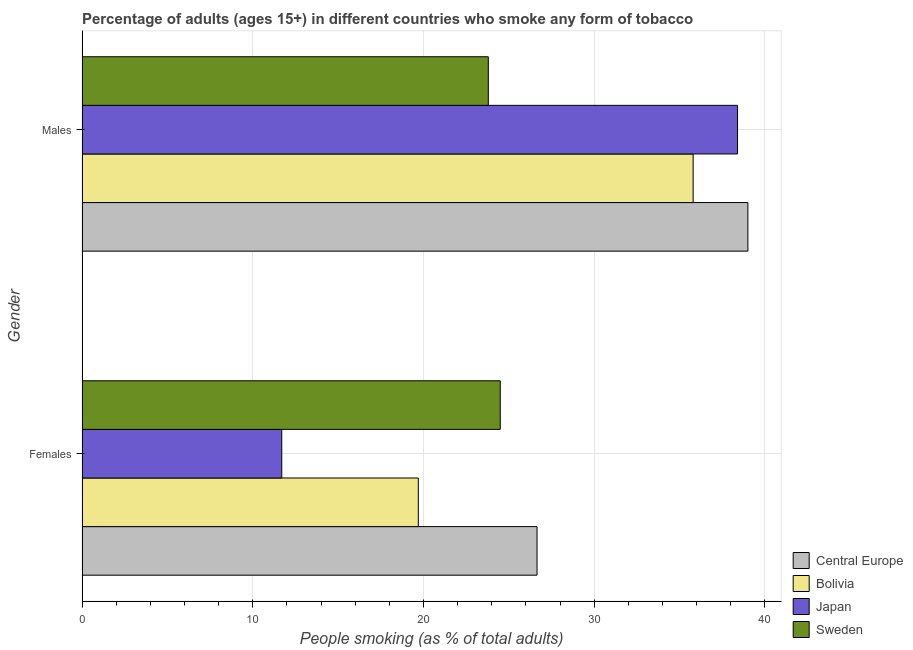How many groups of bars are there?
Offer a terse response. 2. Are the number of bars on each tick of the Y-axis equal?
Make the answer very short. Yes. What is the label of the 2nd group of bars from the top?
Provide a short and direct response. Females. What is the percentage of females who smoke in Sweden?
Offer a very short reply. 24.5. Across all countries, what is the maximum percentage of males who smoke?
Make the answer very short. 39.01. Across all countries, what is the minimum percentage of females who smoke?
Your answer should be very brief. 11.7. In which country was the percentage of males who smoke maximum?
Ensure brevity in your answer.  Central Europe. In which country was the percentage of males who smoke minimum?
Make the answer very short. Sweden. What is the total percentage of males who smoke in the graph?
Ensure brevity in your answer.  137.01. What is the difference between the percentage of males who smoke in Sweden and that in Bolivia?
Keep it short and to the point. -12. What is the difference between the percentage of females who smoke in Bolivia and the percentage of males who smoke in Japan?
Your answer should be compact. -18.7. What is the average percentage of females who smoke per country?
Your answer should be very brief. 20.64. What is the difference between the percentage of males who smoke and percentage of females who smoke in Central Europe?
Your response must be concise. 12.35. In how many countries, is the percentage of females who smoke greater than 14 %?
Provide a succinct answer. 3. What is the ratio of the percentage of males who smoke in Bolivia to that in Japan?
Offer a terse response. 0.93. What does the 3rd bar from the top in Males represents?
Offer a very short reply. Bolivia. Are all the bars in the graph horizontal?
Keep it short and to the point. Yes. Does the graph contain any zero values?
Your answer should be compact. No. Does the graph contain grids?
Give a very brief answer. Yes. How many legend labels are there?
Your answer should be compact. 4. What is the title of the graph?
Offer a very short reply. Percentage of adults (ages 15+) in different countries who smoke any form of tobacco. What is the label or title of the X-axis?
Give a very brief answer. People smoking (as % of total adults). What is the People smoking (as % of total adults) in Central Europe in Females?
Keep it short and to the point. 26.65. What is the People smoking (as % of total adults) in Central Europe in Males?
Offer a terse response. 39.01. What is the People smoking (as % of total adults) in Bolivia in Males?
Your answer should be very brief. 35.8. What is the People smoking (as % of total adults) in Japan in Males?
Offer a very short reply. 38.4. What is the People smoking (as % of total adults) of Sweden in Males?
Provide a short and direct response. 23.8. Across all Gender, what is the maximum People smoking (as % of total adults) of Central Europe?
Your answer should be very brief. 39.01. Across all Gender, what is the maximum People smoking (as % of total adults) of Bolivia?
Ensure brevity in your answer.  35.8. Across all Gender, what is the maximum People smoking (as % of total adults) of Japan?
Your answer should be compact. 38.4. Across all Gender, what is the maximum People smoking (as % of total adults) of Sweden?
Your answer should be very brief. 24.5. Across all Gender, what is the minimum People smoking (as % of total adults) in Central Europe?
Provide a succinct answer. 26.65. Across all Gender, what is the minimum People smoking (as % of total adults) of Bolivia?
Your answer should be compact. 19.7. Across all Gender, what is the minimum People smoking (as % of total adults) in Japan?
Provide a short and direct response. 11.7. Across all Gender, what is the minimum People smoking (as % of total adults) in Sweden?
Your answer should be very brief. 23.8. What is the total People smoking (as % of total adults) in Central Europe in the graph?
Your answer should be very brief. 65.66. What is the total People smoking (as % of total adults) of Bolivia in the graph?
Keep it short and to the point. 55.5. What is the total People smoking (as % of total adults) in Japan in the graph?
Give a very brief answer. 50.1. What is the total People smoking (as % of total adults) in Sweden in the graph?
Your response must be concise. 48.3. What is the difference between the People smoking (as % of total adults) in Central Europe in Females and that in Males?
Offer a very short reply. -12.35. What is the difference between the People smoking (as % of total adults) of Bolivia in Females and that in Males?
Provide a short and direct response. -16.1. What is the difference between the People smoking (as % of total adults) of Japan in Females and that in Males?
Your response must be concise. -26.7. What is the difference between the People smoking (as % of total adults) of Central Europe in Females and the People smoking (as % of total adults) of Bolivia in Males?
Provide a short and direct response. -9.14. What is the difference between the People smoking (as % of total adults) in Central Europe in Females and the People smoking (as % of total adults) in Japan in Males?
Make the answer very short. -11.74. What is the difference between the People smoking (as % of total adults) of Central Europe in Females and the People smoking (as % of total adults) of Sweden in Males?
Provide a short and direct response. 2.85. What is the difference between the People smoking (as % of total adults) of Bolivia in Females and the People smoking (as % of total adults) of Japan in Males?
Provide a succinct answer. -18.7. What is the difference between the People smoking (as % of total adults) of Japan in Females and the People smoking (as % of total adults) of Sweden in Males?
Keep it short and to the point. -12.1. What is the average People smoking (as % of total adults) of Central Europe per Gender?
Keep it short and to the point. 32.83. What is the average People smoking (as % of total adults) of Bolivia per Gender?
Provide a succinct answer. 27.75. What is the average People smoking (as % of total adults) of Japan per Gender?
Ensure brevity in your answer.  25.05. What is the average People smoking (as % of total adults) of Sweden per Gender?
Keep it short and to the point. 24.15. What is the difference between the People smoking (as % of total adults) of Central Europe and People smoking (as % of total adults) of Bolivia in Females?
Provide a succinct answer. 6.96. What is the difference between the People smoking (as % of total adults) in Central Europe and People smoking (as % of total adults) in Japan in Females?
Give a very brief answer. 14.96. What is the difference between the People smoking (as % of total adults) of Central Europe and People smoking (as % of total adults) of Sweden in Females?
Offer a terse response. 2.15. What is the difference between the People smoking (as % of total adults) in Bolivia and People smoking (as % of total adults) in Sweden in Females?
Your answer should be compact. -4.8. What is the difference between the People smoking (as % of total adults) in Central Europe and People smoking (as % of total adults) in Bolivia in Males?
Provide a succinct answer. 3.21. What is the difference between the People smoking (as % of total adults) of Central Europe and People smoking (as % of total adults) of Japan in Males?
Offer a terse response. 0.61. What is the difference between the People smoking (as % of total adults) of Central Europe and People smoking (as % of total adults) of Sweden in Males?
Give a very brief answer. 15.21. What is the difference between the People smoking (as % of total adults) in Bolivia and People smoking (as % of total adults) in Japan in Males?
Make the answer very short. -2.6. What is the difference between the People smoking (as % of total adults) in Japan and People smoking (as % of total adults) in Sweden in Males?
Offer a very short reply. 14.6. What is the ratio of the People smoking (as % of total adults) of Central Europe in Females to that in Males?
Offer a very short reply. 0.68. What is the ratio of the People smoking (as % of total adults) of Bolivia in Females to that in Males?
Your answer should be very brief. 0.55. What is the ratio of the People smoking (as % of total adults) of Japan in Females to that in Males?
Give a very brief answer. 0.3. What is the ratio of the People smoking (as % of total adults) of Sweden in Females to that in Males?
Make the answer very short. 1.03. What is the difference between the highest and the second highest People smoking (as % of total adults) in Central Europe?
Offer a very short reply. 12.35. What is the difference between the highest and the second highest People smoking (as % of total adults) in Bolivia?
Your response must be concise. 16.1. What is the difference between the highest and the second highest People smoking (as % of total adults) in Japan?
Make the answer very short. 26.7. What is the difference between the highest and the lowest People smoking (as % of total adults) of Central Europe?
Your response must be concise. 12.35. What is the difference between the highest and the lowest People smoking (as % of total adults) of Japan?
Ensure brevity in your answer.  26.7. What is the difference between the highest and the lowest People smoking (as % of total adults) of Sweden?
Provide a succinct answer. 0.7. 